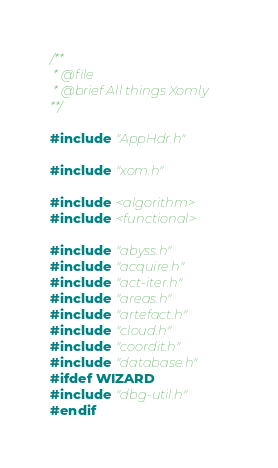<code> <loc_0><loc_0><loc_500><loc_500><_C++_>/**
 * @file
 * @brief All things Xomly
**/

#include "AppHdr.h"

#include "xom.h"

#include <algorithm>
#include <functional>

#include "abyss.h"
#include "acquire.h"
#include "act-iter.h"
#include "areas.h"
#include "artefact.h"
#include "cloud.h"
#include "coordit.h"
#include "database.h"
#ifdef WIZARD
#include "dbg-util.h"
#endif</code> 